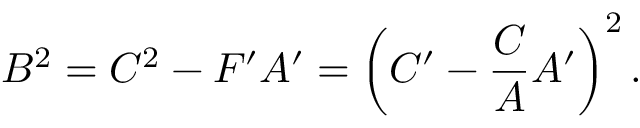<formula> <loc_0><loc_0><loc_500><loc_500>B ^ { 2 } = C ^ { 2 } - F ^ { \prime } A ^ { \prime } = \left ( C ^ { \prime } - \frac { C } { A } A ^ { \prime } \right ) ^ { 2 } .</formula> 